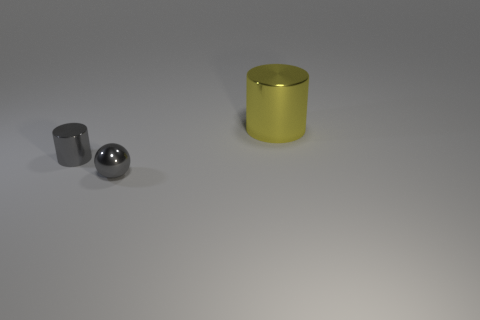Add 1 large cylinders. How many objects exist? 4 Subtract all cylinders. How many objects are left? 1 Add 1 yellow balls. How many yellow balls exist? 1 Subtract 0 yellow blocks. How many objects are left? 3 Subtract all tiny gray shiny things. Subtract all big yellow metallic cylinders. How many objects are left? 0 Add 3 large yellow cylinders. How many large yellow cylinders are left? 4 